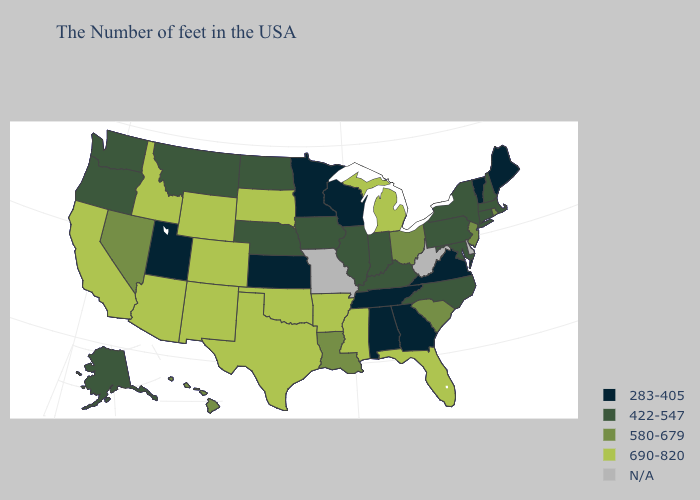What is the value of West Virginia?
Be succinct. N/A. Does the map have missing data?
Answer briefly. Yes. Name the states that have a value in the range N/A?
Give a very brief answer. Delaware, West Virginia, Missouri. What is the lowest value in states that border Texas?
Quick response, please. 580-679. What is the value of Iowa?
Write a very short answer. 422-547. Which states have the lowest value in the USA?
Give a very brief answer. Maine, Vermont, Virginia, Georgia, Alabama, Tennessee, Wisconsin, Minnesota, Kansas, Utah. What is the value of Oregon?
Be succinct. 422-547. Does Hawaii have the highest value in the West?
Keep it brief. No. What is the highest value in the USA?
Be succinct. 690-820. Which states have the lowest value in the MidWest?
Answer briefly. Wisconsin, Minnesota, Kansas. What is the highest value in the USA?
Short answer required. 690-820. What is the value of Utah?
Be succinct. 283-405. What is the value of Utah?
Quick response, please. 283-405. 